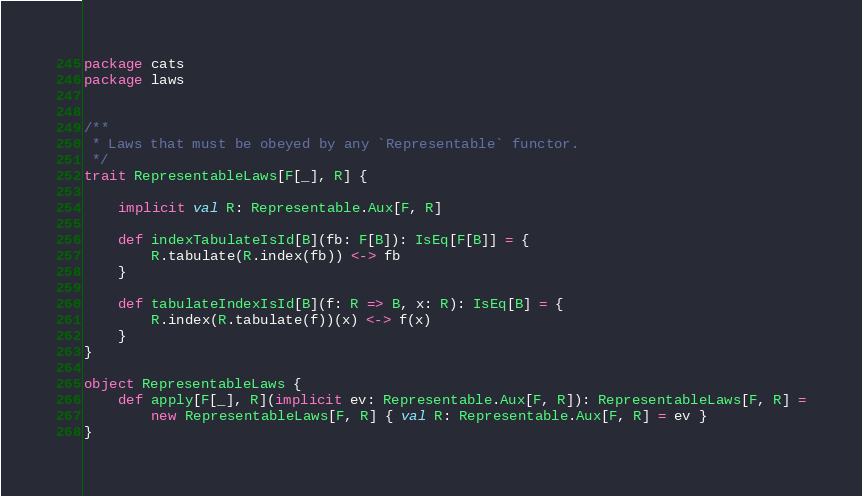<code> <loc_0><loc_0><loc_500><loc_500><_Scala_>package cats
package laws


/**
 * Laws that must be obeyed by any `Representable` functor.
 */
trait RepresentableLaws[F[_], R] {

    implicit val R: Representable.Aux[F, R]

    def indexTabulateIsId[B](fb: F[B]): IsEq[F[B]] = {
        R.tabulate(R.index(fb)) <-> fb
    }

    def tabulateIndexIsId[B](f: R => B, x: R): IsEq[B] = {
        R.index(R.tabulate(f))(x) <-> f(x)
    }
}

object RepresentableLaws {
    def apply[F[_], R](implicit ev: Representable.Aux[F, R]): RepresentableLaws[F, R] =
        new RepresentableLaws[F, R] { val R: Representable.Aux[F, R] = ev }
}
</code> 